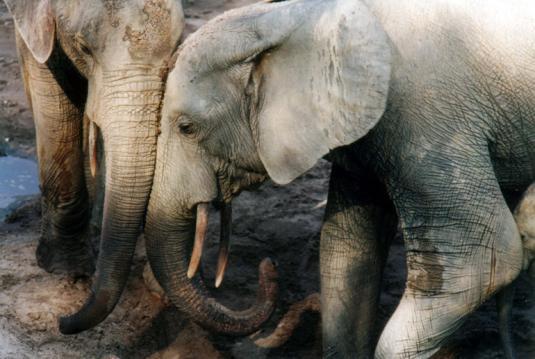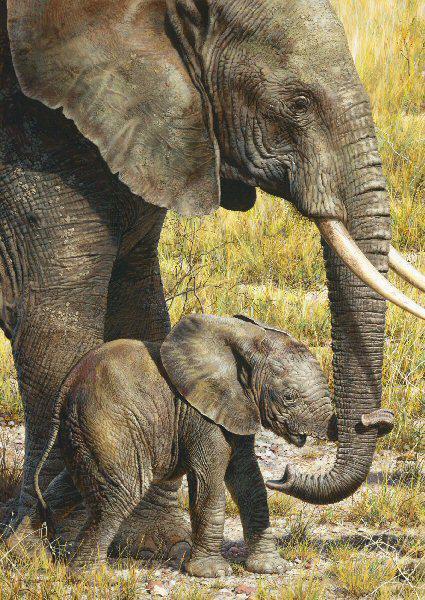The first image is the image on the left, the second image is the image on the right. Given the left and right images, does the statement "The animals in the image on the left are in a muddy area." hold true? Answer yes or no. Yes. The first image is the image on the left, the second image is the image on the right. Analyze the images presented: Is the assertion "There are at most 3 elephants in the pair of images." valid? Answer yes or no. No. 